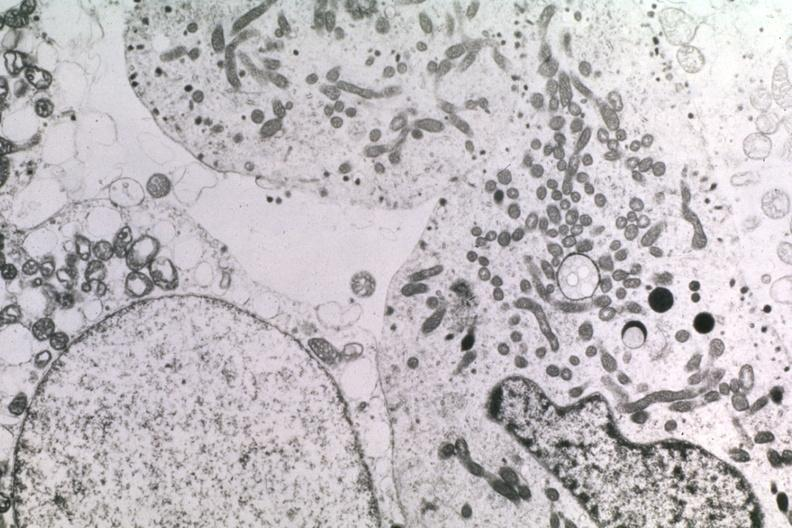what is present?
Answer the question using a single word or phrase. Pituitary 